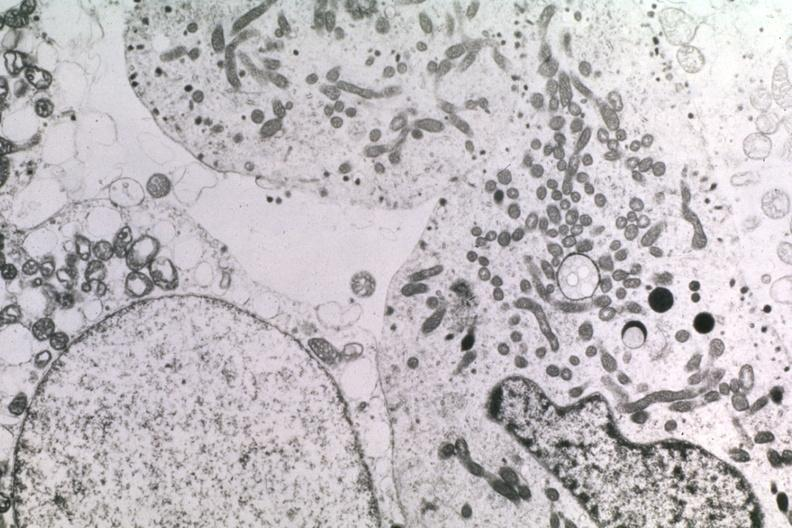what is present?
Answer the question using a single word or phrase. Pituitary 